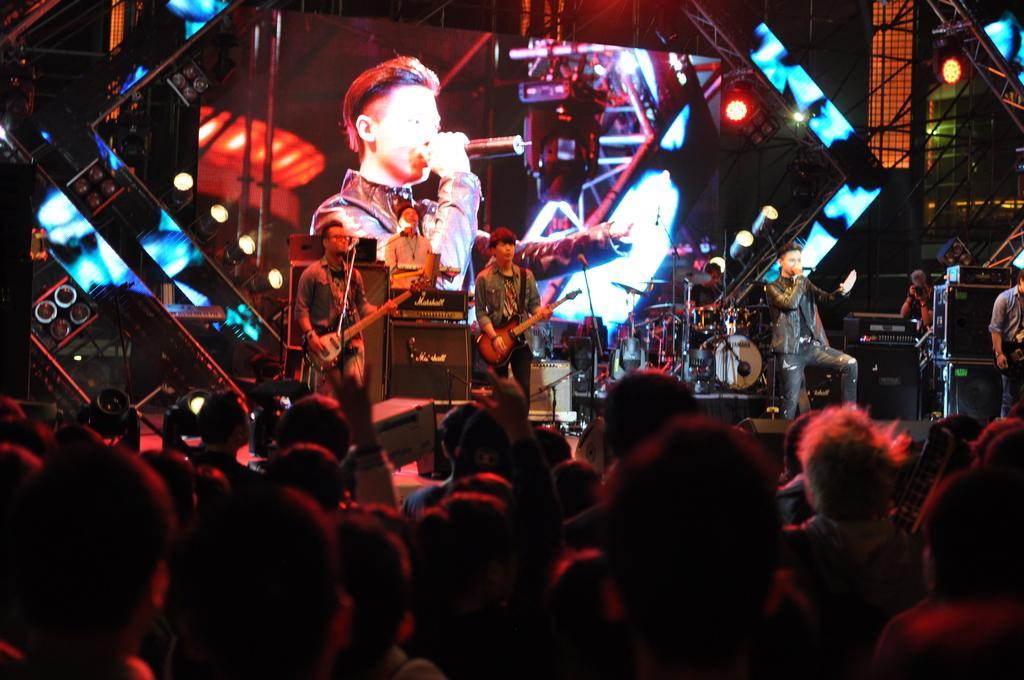Could you give a brief overview of what you see in this image? In this image I see few people on the stage and these two are holding the guitars and this man is holding the mic and I see that this man is holding a camera and I see lot of people over here. In the background I see the lights and the screen. 